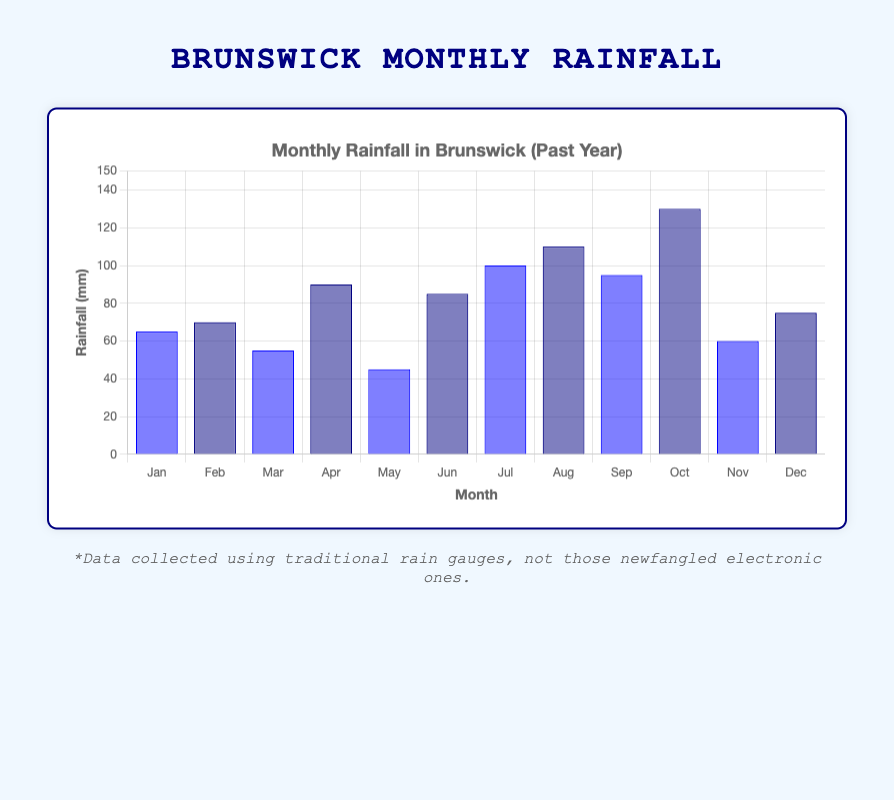Which month had the highest rainfall? The highest bar in the chart represents the month with the highest rainfall. From the chart, October has the tallest bar, indicating the highest rainfall.
Answer: October What was the total rainfall for the summer months (June, July, August)? Sum up the rainfall values for June, July, and August: (85 mm) + (100 mm) + (110 mm) = 295 mm.
Answer: 295 mm How does February's rainfall compare to March's rainfall? February's bar is taller than March's bar. February has a rainfall of 70 mm, while March has 55 mm, indicating that February's rainfall is higher.
Answer: February has higher rainfall Which month had the least amount of rainfall? The shortest bar on the chart represents the month with the lowest rainfall. May has the shortest bar, indicating it received the least rainfall.
Answer: May What is the average rainfall over the year? Sum all monthly rainfall values and divide by 12: (65 + 70 + 55 + 90 + 45 + 85 + 100 + 110 + 95 + 130 + 60 + 75) / 12 = 980/12 ≈ 81.67 mm
Answer: 81.67 mm Was there more rainfall in the first half of the year or the second half? Sum the rainfall for the first half (January to June) and the second half (July to December): First half = 65 + 70 + 55 + 90 + 45 + 85 = 410 mm, Second half = 100 + 110 + 95 + 130 + 60 + 75 = 570 mm. The second half had more rainfall.
Answer: Second half How much more rainfall did October have compared to November? Subtract November's rainfall from October's rainfall: 130 mm - 60 mm = 70 mm.
Answer: 70 mm Which two consecutive months had the largest increase in rainfall? Calculate the difference in rainfall between each pair of consecutive months and find the largest difference: April to May = -45 mm, May to June = 40 mm, June to July = 15 mm, July to August = 10 mm, August to September = -15 mm, September to October = 35 mm, October to November = -70 mm, November to December = 15 mm. The largest increase is from May to June = 40 mm.
Answer: May to June Is there a general trend visible in the monthly rainfall throughout the year? Visually inspecting the chart, there's an increasing trend with fluctuations, peaking in October before a slight decrease at the end of the year.
Answer: Increasing trend with fluctuations Which color represents the rainfall in odd-numbered months and how does it visually compare to the even-numbered months? Odd-numbered months have the lighter blue bars, while even-numbered months have the darker blue bars. On average, the lighter blue bars appear taller throughout the chart.
Answer: Lighter blue bars are taller 